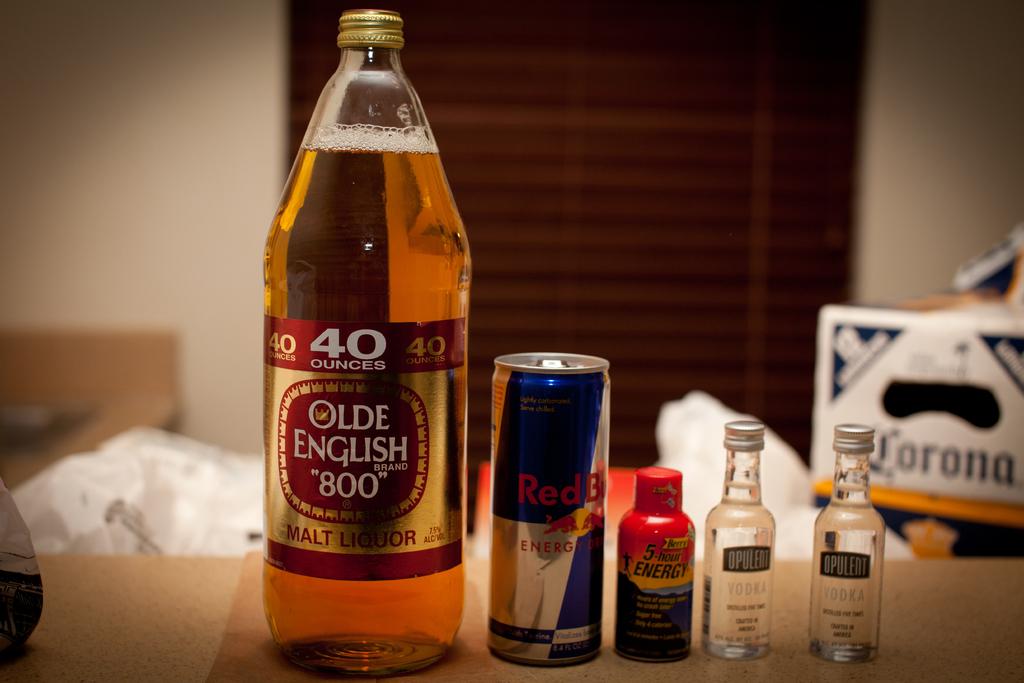How many ounces is the bottle of olde english?
Offer a very short reply. 40. What drink is that?
Your answer should be very brief. Beer. 